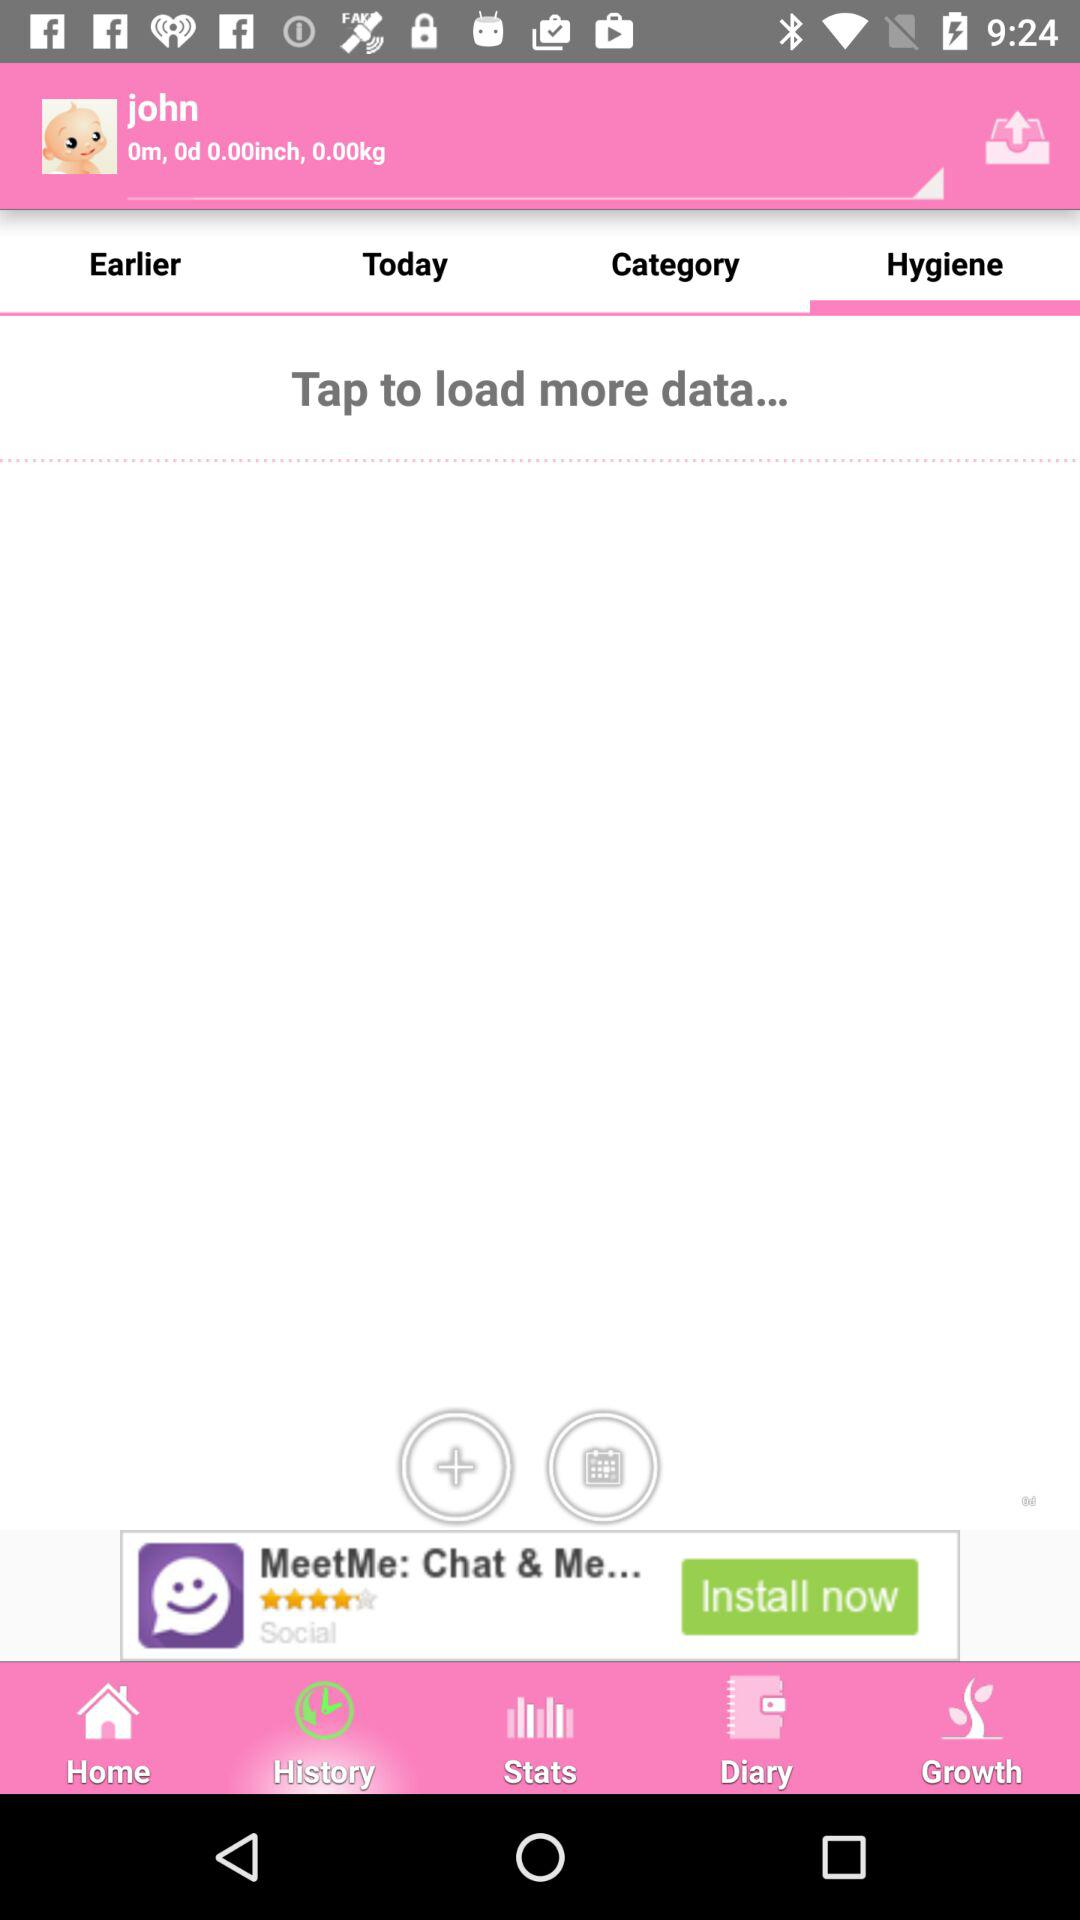Which tab has been selected? The selected tab is "Hygien". 